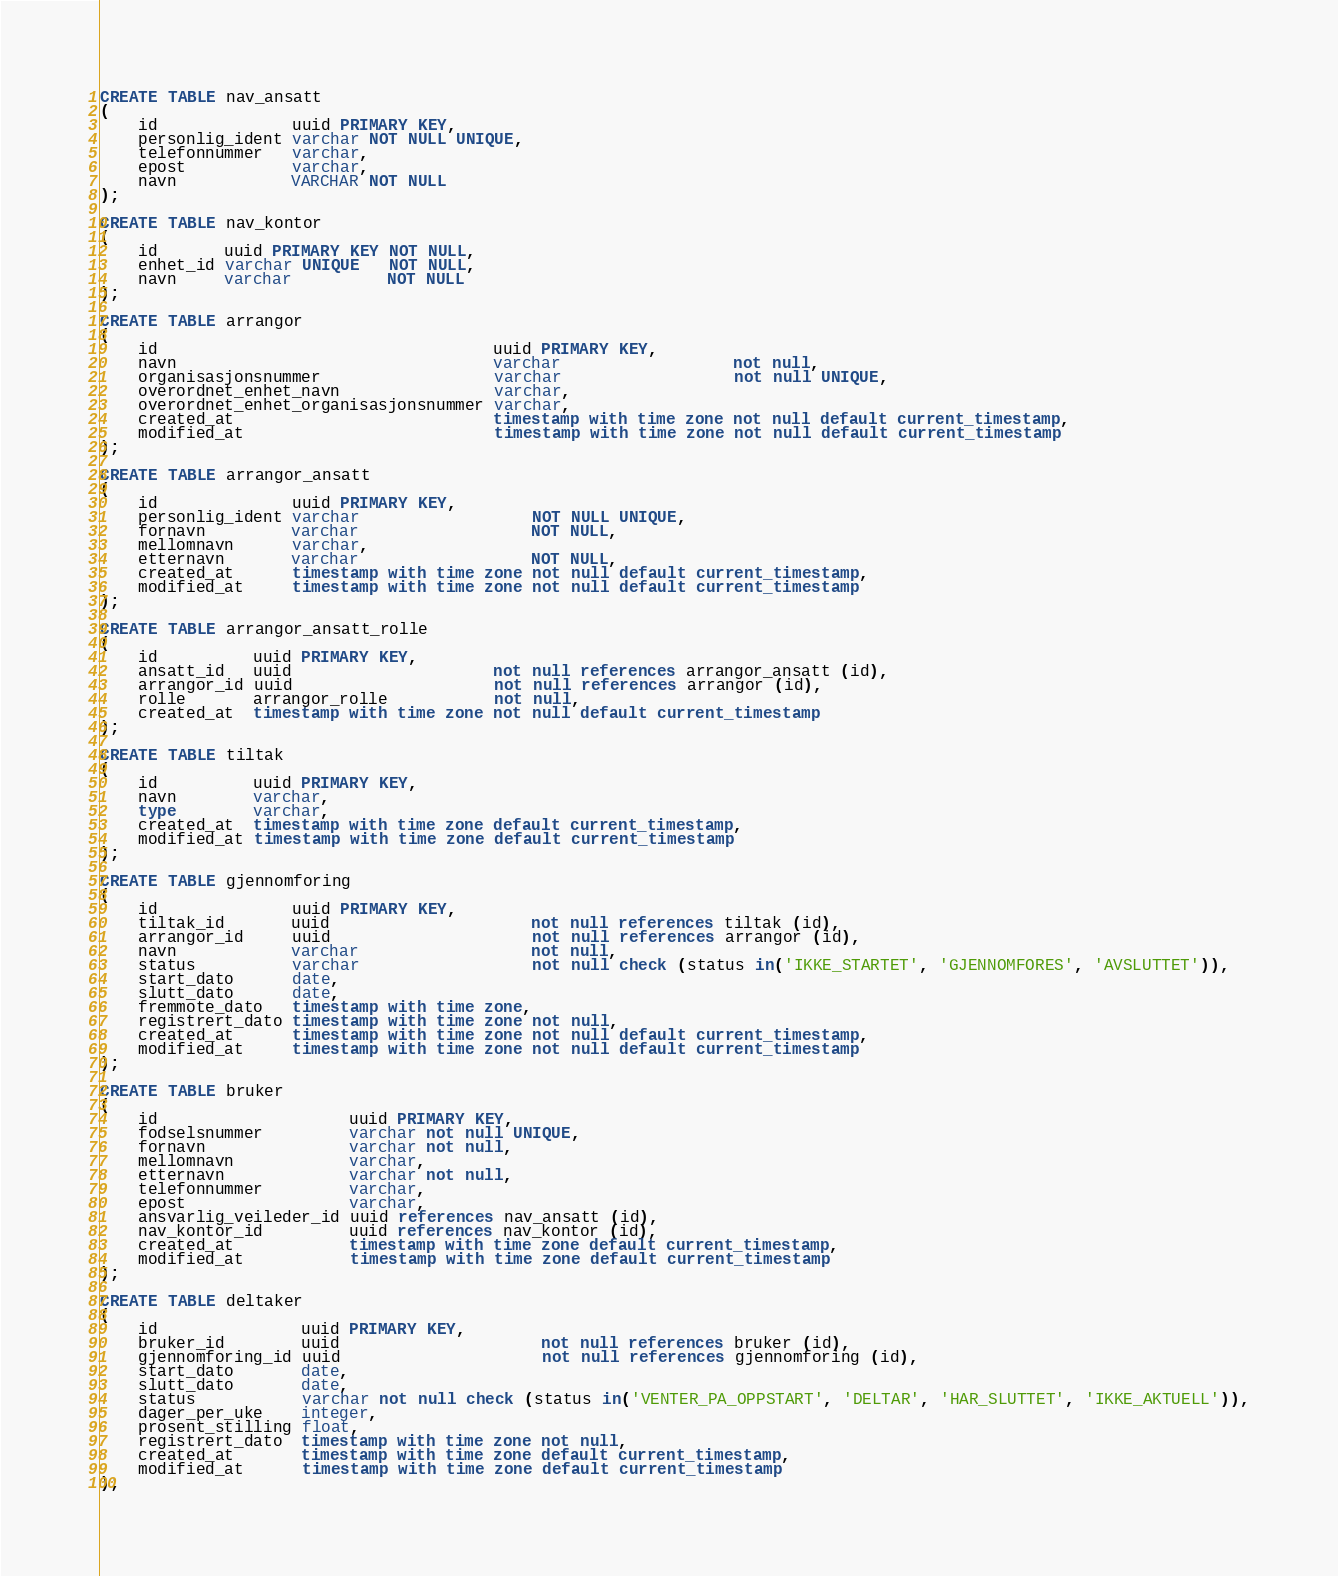<code> <loc_0><loc_0><loc_500><loc_500><_SQL_>CREATE TABLE nav_ansatt
(
    id              uuid PRIMARY KEY,
    personlig_ident varchar NOT NULL UNIQUE,
    telefonnummer   varchar,
    epost           varchar,
    navn            VARCHAR NOT NULL
);

CREATE TABLE nav_kontor
(
    id       uuid PRIMARY KEY NOT NULL,
    enhet_id varchar UNIQUE   NOT NULL,
    navn     varchar          NOT NULL
);

CREATE TABLE arrangor
(
    id                                   uuid PRIMARY KEY,
    navn                                 varchar                  not null,
    organisasjonsnummer                  varchar                  not null UNIQUE,
    overordnet_enhet_navn                varchar,
    overordnet_enhet_organisasjonsnummer varchar,
    created_at                           timestamp with time zone not null default current_timestamp,
    modified_at                          timestamp with time zone not null default current_timestamp
);

CREATE TABLE arrangor_ansatt
(
    id              uuid PRIMARY KEY,
    personlig_ident varchar                  NOT NULL UNIQUE,
    fornavn         varchar                  NOT NULL,
    mellomnavn      varchar,
    etternavn       varchar                  NOT NULL,
    created_at      timestamp with time zone not null default current_timestamp,
    modified_at     timestamp with time zone not null default current_timestamp
);

CREATE TABLE arrangor_ansatt_rolle
(
    id          uuid PRIMARY KEY,
    ansatt_id   uuid                     not null references arrangor_ansatt (id),
    arrangor_id uuid                     not null references arrangor (id),
    rolle       arrangor_rolle           not null,
    created_at  timestamp with time zone not null default current_timestamp
);

CREATE TABLE tiltak
(
    id          uuid PRIMARY KEY,
    navn        varchar,
    type        varchar,
    created_at  timestamp with time zone default current_timestamp,
    modified_at timestamp with time zone default current_timestamp
);

CREATE TABLE gjennomforing
(
    id              uuid PRIMARY KEY,
    tiltak_id       uuid                     not null references tiltak (id),
    arrangor_id     uuid                     not null references arrangor (id),
    navn            varchar                  not null,
    status          varchar                  not null check (status in('IKKE_STARTET', 'GJENNOMFORES', 'AVSLUTTET')),
    start_dato      date,
    slutt_dato      date,
    fremmote_dato   timestamp with time zone,
    registrert_dato timestamp with time zone not null,
    created_at      timestamp with time zone not null default current_timestamp,
    modified_at     timestamp with time zone not null default current_timestamp
);

CREATE TABLE bruker
(
    id                    uuid PRIMARY KEY,
    fodselsnummer         varchar not null UNIQUE,
    fornavn               varchar not null,
    mellomnavn            varchar,
    etternavn             varchar not null,
    telefonnummer         varchar,
    epost                 varchar,
    ansvarlig_veileder_id uuid references nav_ansatt (id),
    nav_kontor_id         uuid references nav_kontor (id),
    created_at            timestamp with time zone default current_timestamp,
    modified_at           timestamp with time zone default current_timestamp
);

CREATE TABLE deltaker
(
    id               uuid PRIMARY KEY,
    bruker_id        uuid                     not null references bruker (id),
    gjennomforing_id uuid                     not null references gjennomforing (id),
    start_dato       date,
    slutt_dato       date,
    status           varchar not null check (status in('VENTER_PA_OPPSTART', 'DELTAR', 'HAR_SLUTTET', 'IKKE_AKTUELL')),
    dager_per_uke    integer,
    prosent_stilling float,
    registrert_dato  timestamp with time zone not null,
    created_at       timestamp with time zone default current_timestamp,
    modified_at      timestamp with time zone default current_timestamp
);
</code> 